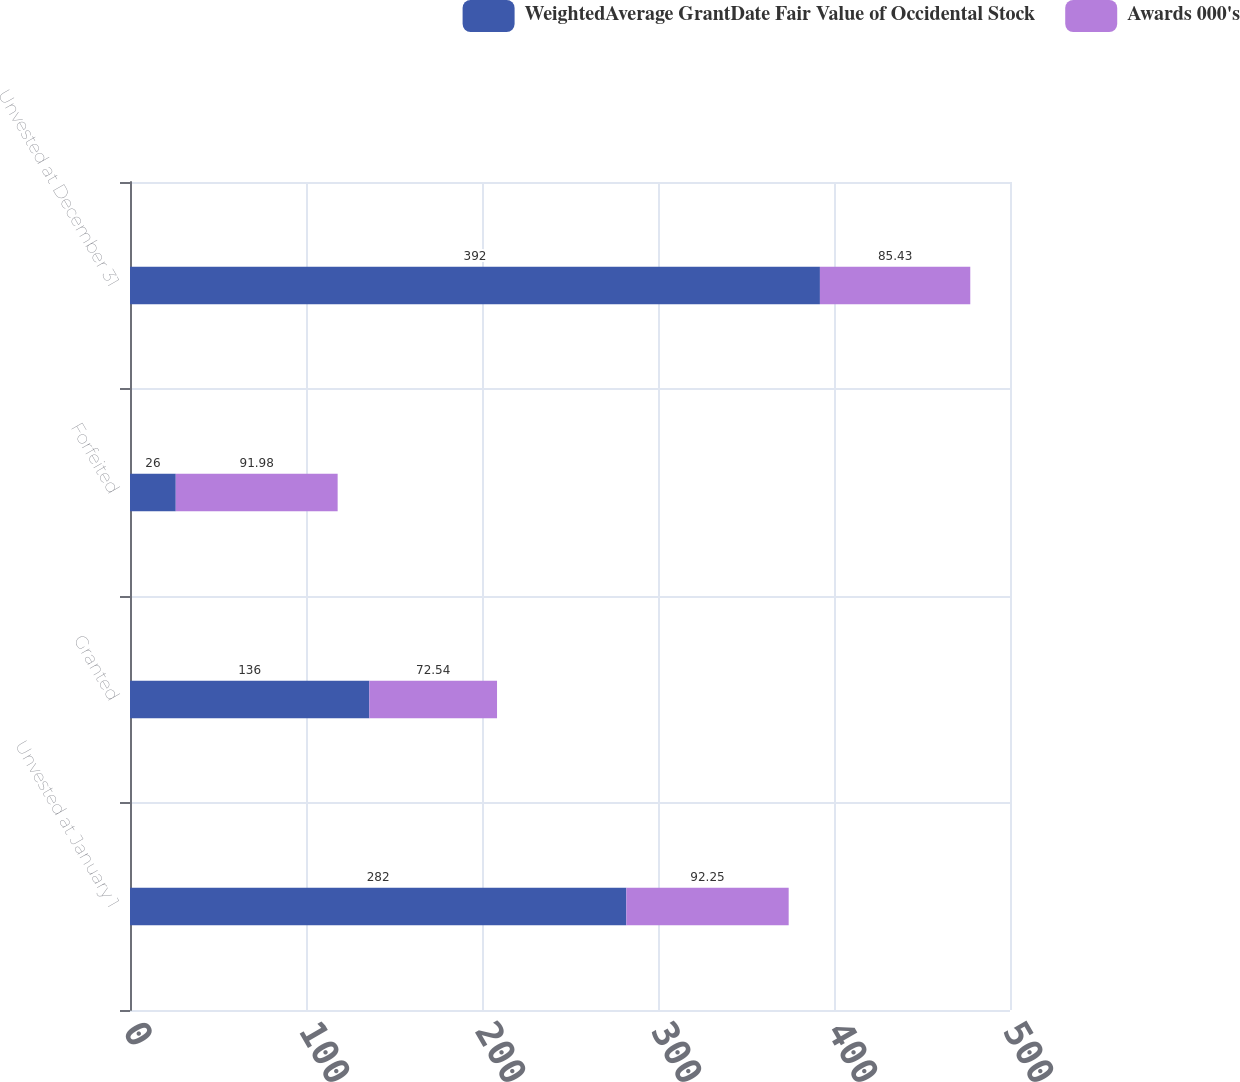<chart> <loc_0><loc_0><loc_500><loc_500><stacked_bar_chart><ecel><fcel>Unvested at January 1<fcel>Granted<fcel>Forfeited<fcel>Unvested at December 31<nl><fcel>WeightedAverage GrantDate Fair Value of Occidental Stock<fcel>282<fcel>136<fcel>26<fcel>392<nl><fcel>Awards 000's<fcel>92.25<fcel>72.54<fcel>91.98<fcel>85.43<nl></chart> 